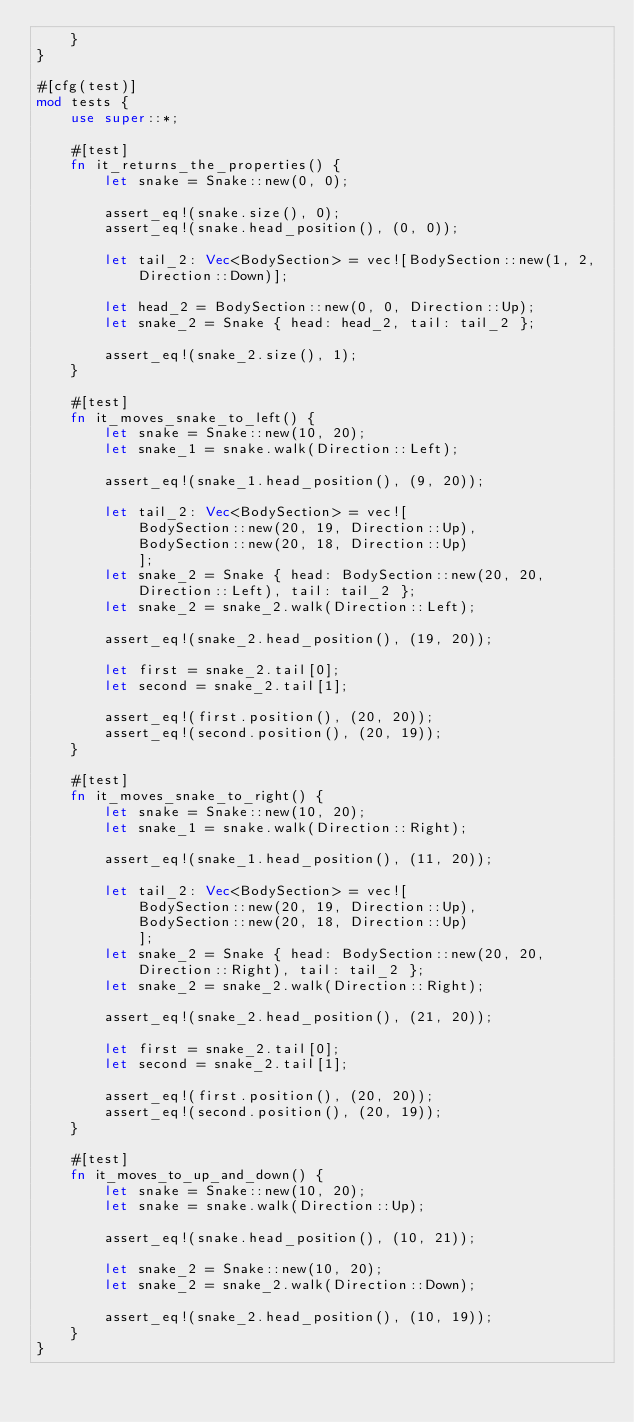Convert code to text. <code><loc_0><loc_0><loc_500><loc_500><_Rust_>    }
}

#[cfg(test)]
mod tests {
    use super::*;

    #[test]
    fn it_returns_the_properties() {
        let snake = Snake::new(0, 0);

        assert_eq!(snake.size(), 0);
        assert_eq!(snake.head_position(), (0, 0));

        let tail_2: Vec<BodySection> = vec![BodySection::new(1, 2, Direction::Down)];

        let head_2 = BodySection::new(0, 0, Direction::Up);
        let snake_2 = Snake { head: head_2, tail: tail_2 };

        assert_eq!(snake_2.size(), 1);
    }

    #[test]
    fn it_moves_snake_to_left() {
        let snake = Snake::new(10, 20);
        let snake_1 = snake.walk(Direction::Left);

        assert_eq!(snake_1.head_position(), (9, 20));

        let tail_2: Vec<BodySection> = vec![
            BodySection::new(20, 19, Direction::Up),
            BodySection::new(20, 18, Direction::Up)
            ];
        let snake_2 = Snake { head: BodySection::new(20, 20, Direction::Left), tail: tail_2 };
        let snake_2 = snake_2.walk(Direction::Left);

        assert_eq!(snake_2.head_position(), (19, 20));

        let first = snake_2.tail[0];
        let second = snake_2.tail[1];

        assert_eq!(first.position(), (20, 20));
        assert_eq!(second.position(), (20, 19));
    }

    #[test]
    fn it_moves_snake_to_right() {
        let snake = Snake::new(10, 20);
        let snake_1 = snake.walk(Direction::Right);

        assert_eq!(snake_1.head_position(), (11, 20));

        let tail_2: Vec<BodySection> = vec![
            BodySection::new(20, 19, Direction::Up),
            BodySection::new(20, 18, Direction::Up)
            ];
        let snake_2 = Snake { head: BodySection::new(20, 20, Direction::Right), tail: tail_2 };
        let snake_2 = snake_2.walk(Direction::Right);

        assert_eq!(snake_2.head_position(), (21, 20));

        let first = snake_2.tail[0];
        let second = snake_2.tail[1];

        assert_eq!(first.position(), (20, 20));
        assert_eq!(second.position(), (20, 19));
    }

    #[test]
    fn it_moves_to_up_and_down() {
        let snake = Snake::new(10, 20);
        let snake = snake.walk(Direction::Up);

        assert_eq!(snake.head_position(), (10, 21));

        let snake_2 = Snake::new(10, 20);
        let snake_2 = snake_2.walk(Direction::Down);

        assert_eq!(snake_2.head_position(), (10, 19));
    }
}
</code> 